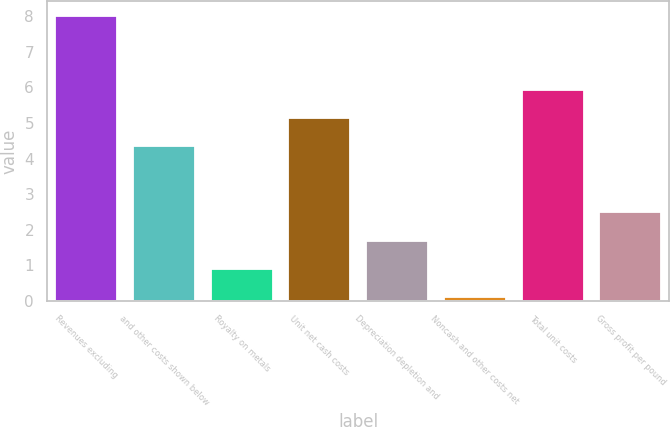Convert chart to OTSL. <chart><loc_0><loc_0><loc_500><loc_500><bar_chart><fcel>Revenues excluding<fcel>and other costs shown below<fcel>Royalty on metals<fcel>Unit net cash costs<fcel>Depreciation depletion and<fcel>Noncash and other costs net<fcel>Total unit costs<fcel>Gross profit per pound<nl><fcel>8.02<fcel>4.35<fcel>0.9<fcel>5.14<fcel>1.69<fcel>0.11<fcel>5.93<fcel>2.51<nl></chart> 